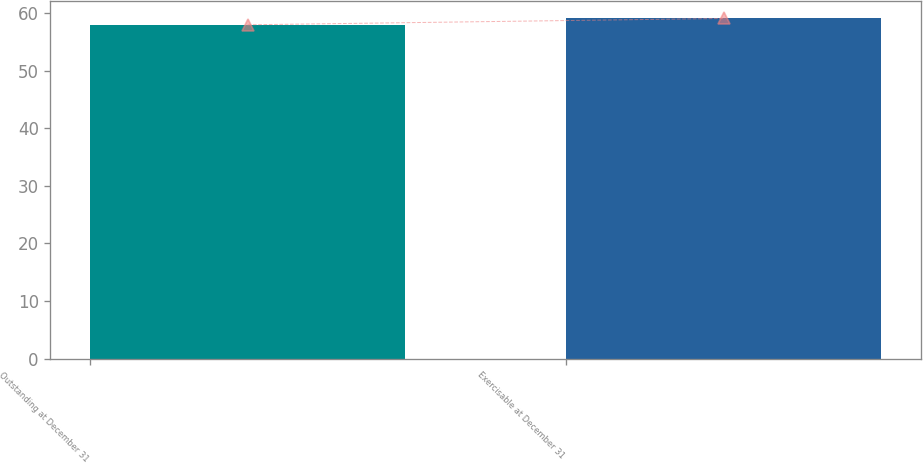Convert chart. <chart><loc_0><loc_0><loc_500><loc_500><bar_chart><fcel>Outstanding at December 31<fcel>Exercisable at December 31<nl><fcel>58<fcel>59.1<nl></chart> 